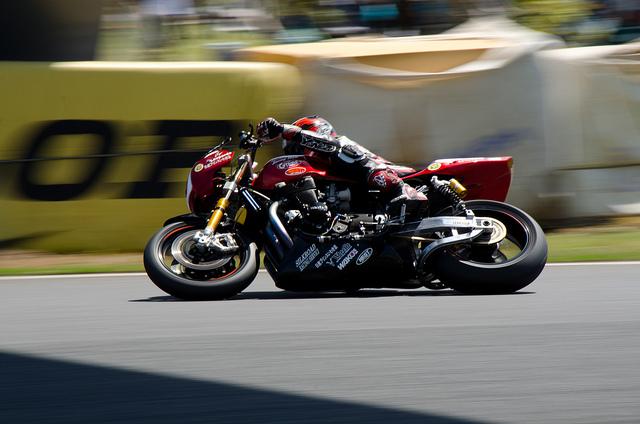Is the bike upright?
Give a very brief answer. No. What color is the bike?
Write a very short answer. Red. Is the bike black?
Write a very short answer. No. What kind of motorcycle is this?
Be succinct. Racing. What color is the motorcycle?
Write a very short answer. Red. 